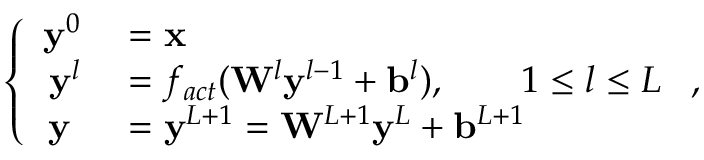Convert formula to latex. <formula><loc_0><loc_0><loc_500><loc_500>\left \{ \begin{array} { r l } { y ^ { 0 } } & = x } \\ { y ^ { l } } & = f _ { a c t } ( W ^ { l } y ^ { l - 1 } + b ^ { l } ) , \quad 1 \leq l \leq L } \\ { y \, } & = y ^ { L + 1 } = W ^ { L + 1 } y ^ { L } + b ^ { L + 1 } } \end{array} ,</formula> 